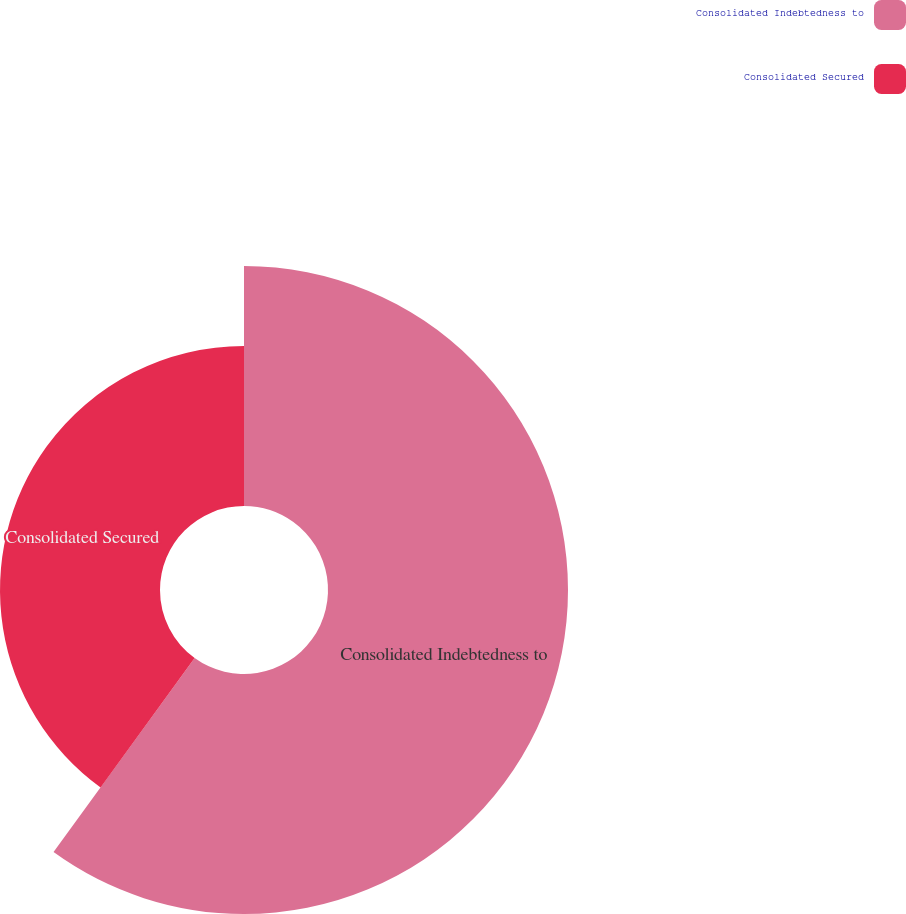Convert chart. <chart><loc_0><loc_0><loc_500><loc_500><pie_chart><fcel>Consolidated Indebtedness to<fcel>Consolidated Secured<nl><fcel>60.0%<fcel>40.0%<nl></chart> 